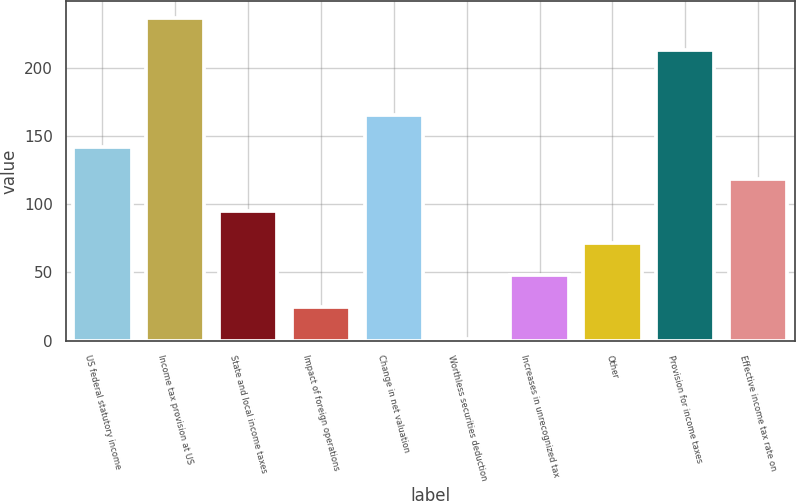Convert chart. <chart><loc_0><loc_0><loc_500><loc_500><bar_chart><fcel>US federal statutory income<fcel>Income tax provision at US<fcel>State and local income taxes<fcel>Impact of foreign operations<fcel>Change in net valuation<fcel>Worthless securities deduction<fcel>Increases in unrecognized tax<fcel>Other<fcel>Provision for income taxes<fcel>Effective income tax rate on<nl><fcel>142.26<fcel>236.79<fcel>95.3<fcel>24.84<fcel>165.75<fcel>1.35<fcel>48.33<fcel>71.81<fcel>213.3<fcel>118.78<nl></chart> 